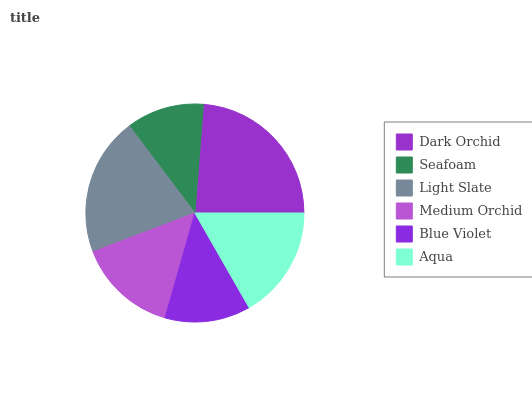Is Seafoam the minimum?
Answer yes or no. Yes. Is Dark Orchid the maximum?
Answer yes or no. Yes. Is Light Slate the minimum?
Answer yes or no. No. Is Light Slate the maximum?
Answer yes or no. No. Is Light Slate greater than Seafoam?
Answer yes or no. Yes. Is Seafoam less than Light Slate?
Answer yes or no. Yes. Is Seafoam greater than Light Slate?
Answer yes or no. No. Is Light Slate less than Seafoam?
Answer yes or no. No. Is Aqua the high median?
Answer yes or no. Yes. Is Medium Orchid the low median?
Answer yes or no. Yes. Is Seafoam the high median?
Answer yes or no. No. Is Blue Violet the low median?
Answer yes or no. No. 